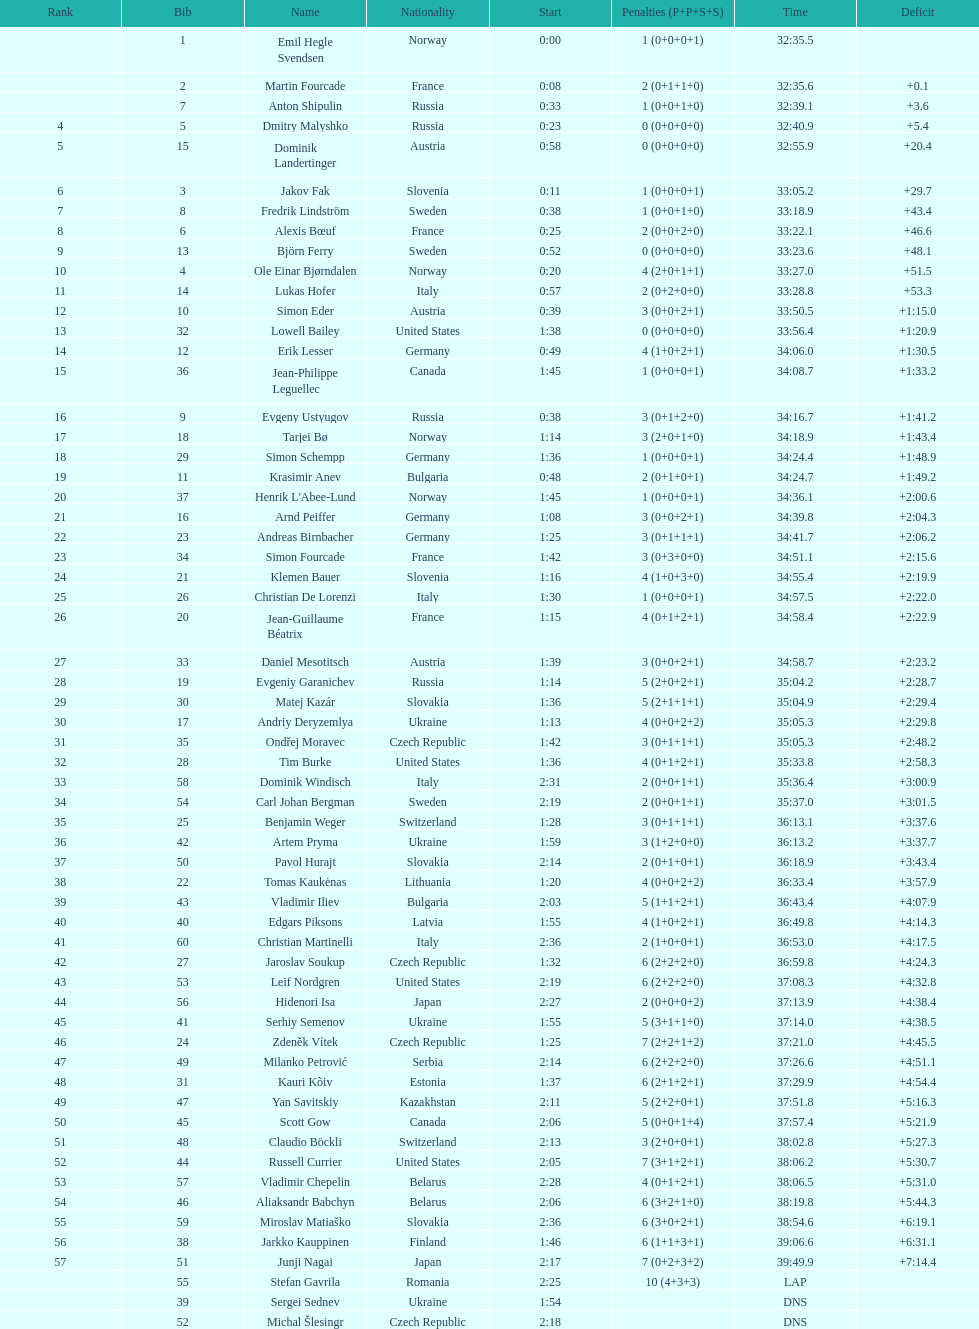What is the most severe penalty? 10. Can you give me this table as a dict? {'header': ['Rank', 'Bib', 'Name', 'Nationality', 'Start', 'Penalties (P+P+S+S)', 'Time', 'Deficit'], 'rows': [['', '1', 'Emil Hegle Svendsen', 'Norway', '0:00', '1 (0+0+0+1)', '32:35.5', ''], ['', '2', 'Martin Fourcade', 'France', '0:08', '2 (0+1+1+0)', '32:35.6', '+0.1'], ['', '7', 'Anton Shipulin', 'Russia', '0:33', '1 (0+0+1+0)', '32:39.1', '+3.6'], ['4', '5', 'Dmitry Malyshko', 'Russia', '0:23', '0 (0+0+0+0)', '32:40.9', '+5.4'], ['5', '15', 'Dominik Landertinger', 'Austria', '0:58', '0 (0+0+0+0)', '32:55.9', '+20.4'], ['6', '3', 'Jakov Fak', 'Slovenia', '0:11', '1 (0+0+0+1)', '33:05.2', '+29.7'], ['7', '8', 'Fredrik Lindström', 'Sweden', '0:38', '1 (0+0+1+0)', '33:18.9', '+43.4'], ['8', '6', 'Alexis Bœuf', 'France', '0:25', '2 (0+0+2+0)', '33:22.1', '+46.6'], ['9', '13', 'Björn Ferry', 'Sweden', '0:52', '0 (0+0+0+0)', '33:23.6', '+48.1'], ['10', '4', 'Ole Einar Bjørndalen', 'Norway', '0:20', '4 (2+0+1+1)', '33:27.0', '+51.5'], ['11', '14', 'Lukas Hofer', 'Italy', '0:57', '2 (0+2+0+0)', '33:28.8', '+53.3'], ['12', '10', 'Simon Eder', 'Austria', '0:39', '3 (0+0+2+1)', '33:50.5', '+1:15.0'], ['13', '32', 'Lowell Bailey', 'United States', '1:38', '0 (0+0+0+0)', '33:56.4', '+1:20.9'], ['14', '12', 'Erik Lesser', 'Germany', '0:49', '4 (1+0+2+1)', '34:06.0', '+1:30.5'], ['15', '36', 'Jean-Philippe Leguellec', 'Canada', '1:45', '1 (0+0+0+1)', '34:08.7', '+1:33.2'], ['16', '9', 'Evgeny Ustyugov', 'Russia', '0:38', '3 (0+1+2+0)', '34:16.7', '+1:41.2'], ['17', '18', 'Tarjei Bø', 'Norway', '1:14', '3 (2+0+1+0)', '34:18.9', '+1:43.4'], ['18', '29', 'Simon Schempp', 'Germany', '1:36', '1 (0+0+0+1)', '34:24.4', '+1:48.9'], ['19', '11', 'Krasimir Anev', 'Bulgaria', '0:48', '2 (0+1+0+1)', '34:24.7', '+1:49.2'], ['20', '37', "Henrik L'Abee-Lund", 'Norway', '1:45', '1 (0+0+0+1)', '34:36.1', '+2:00.6'], ['21', '16', 'Arnd Peiffer', 'Germany', '1:08', '3 (0+0+2+1)', '34:39.8', '+2:04.3'], ['22', '23', 'Andreas Birnbacher', 'Germany', '1:25', '3 (0+1+1+1)', '34:41.7', '+2:06.2'], ['23', '34', 'Simon Fourcade', 'France', '1:42', '3 (0+3+0+0)', '34:51.1', '+2:15.6'], ['24', '21', 'Klemen Bauer', 'Slovenia', '1:16', '4 (1+0+3+0)', '34:55.4', '+2:19.9'], ['25', '26', 'Christian De Lorenzi', 'Italy', '1:30', '1 (0+0+0+1)', '34:57.5', '+2:22.0'], ['26', '20', 'Jean-Guillaume Béatrix', 'France', '1:15', '4 (0+1+2+1)', '34:58.4', '+2:22.9'], ['27', '33', 'Daniel Mesotitsch', 'Austria', '1:39', '3 (0+0+2+1)', '34:58.7', '+2:23.2'], ['28', '19', 'Evgeniy Garanichev', 'Russia', '1:14', '5 (2+0+2+1)', '35:04.2', '+2:28.7'], ['29', '30', 'Matej Kazár', 'Slovakia', '1:36', '5 (2+1+1+1)', '35:04.9', '+2:29.4'], ['30', '17', 'Andriy Deryzemlya', 'Ukraine', '1:13', '4 (0+0+2+2)', '35:05.3', '+2:29.8'], ['31', '35', 'Ondřej Moravec', 'Czech Republic', '1:42', '3 (0+1+1+1)', '35:05.3', '+2:48.2'], ['32', '28', 'Tim Burke', 'United States', '1:36', '4 (0+1+2+1)', '35:33.8', '+2:58.3'], ['33', '58', 'Dominik Windisch', 'Italy', '2:31', '2 (0+0+1+1)', '35:36.4', '+3:00.9'], ['34', '54', 'Carl Johan Bergman', 'Sweden', '2:19', '2 (0+0+1+1)', '35:37.0', '+3:01.5'], ['35', '25', 'Benjamin Weger', 'Switzerland', '1:28', '3 (0+1+1+1)', '36:13.1', '+3:37.6'], ['36', '42', 'Artem Pryma', 'Ukraine', '1:59', '3 (1+2+0+0)', '36:13.2', '+3:37.7'], ['37', '50', 'Pavol Hurajt', 'Slovakia', '2:14', '2 (0+1+0+1)', '36:18.9', '+3:43.4'], ['38', '22', 'Tomas Kaukėnas', 'Lithuania', '1:20', '4 (0+0+2+2)', '36:33.4', '+3:57.9'], ['39', '43', 'Vladimir Iliev', 'Bulgaria', '2:03', '5 (1+1+2+1)', '36:43.4', '+4:07.9'], ['40', '40', 'Edgars Piksons', 'Latvia', '1:55', '4 (1+0+2+1)', '36:49.8', '+4:14.3'], ['41', '60', 'Christian Martinelli', 'Italy', '2:36', '2 (1+0+0+1)', '36:53.0', '+4:17.5'], ['42', '27', 'Jaroslav Soukup', 'Czech Republic', '1:32', '6 (2+2+2+0)', '36:59.8', '+4:24.3'], ['43', '53', 'Leif Nordgren', 'United States', '2:19', '6 (2+2+2+0)', '37:08.3', '+4:32.8'], ['44', '56', 'Hidenori Isa', 'Japan', '2:27', '2 (0+0+0+2)', '37:13.9', '+4:38.4'], ['45', '41', 'Serhiy Semenov', 'Ukraine', '1:55', '5 (3+1+1+0)', '37:14.0', '+4:38.5'], ['46', '24', 'Zdeněk Vítek', 'Czech Republic', '1:25', '7 (2+2+1+2)', '37:21.0', '+4:45.5'], ['47', '49', 'Milanko Petrović', 'Serbia', '2:14', '6 (2+2+2+0)', '37:26.6', '+4:51.1'], ['48', '31', 'Kauri Kõiv', 'Estonia', '1:37', '6 (2+1+2+1)', '37:29.9', '+4:54.4'], ['49', '47', 'Yan Savitskiy', 'Kazakhstan', '2:11', '5 (2+2+0+1)', '37:51.8', '+5:16.3'], ['50', '45', 'Scott Gow', 'Canada', '2:06', '5 (0+0+1+4)', '37:57.4', '+5:21.9'], ['51', '48', 'Claudio Böckli', 'Switzerland', '2:13', '3 (2+0+0+1)', '38:02.8', '+5:27.3'], ['52', '44', 'Russell Currier', 'United States', '2:05', '7 (3+1+2+1)', '38:06.2', '+5:30.7'], ['53', '57', 'Vladimir Chepelin', 'Belarus', '2:28', '4 (0+1+2+1)', '38:06.5', '+5:31.0'], ['54', '46', 'Aliaksandr Babchyn', 'Belarus', '2:06', '6 (3+2+1+0)', '38:19.8', '+5:44.3'], ['55', '59', 'Miroslav Matiaško', 'Slovakia', '2:36', '6 (3+0+2+1)', '38:54.6', '+6:19.1'], ['56', '38', 'Jarkko Kauppinen', 'Finland', '1:46', '6 (1+1+3+1)', '39:06.6', '+6:31.1'], ['57', '51', 'Junji Nagai', 'Japan', '2:17', '7 (0+2+3+2)', '39:49.9', '+7:14.4'], ['', '55', 'Stefan Gavrila', 'Romania', '2:25', '10 (4+3+3)', 'LAP', ''], ['', '39', 'Sergei Sednev', 'Ukraine', '1:54', '', 'DNS', ''], ['', '52', 'Michal Šlesingr', 'Czech Republic', '2:18', '', 'DNS', '']]} 